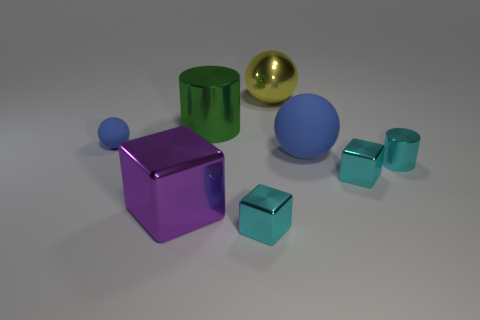Do the big rubber object and the small rubber ball have the same color?
Your answer should be very brief. Yes. What shape is the large green object?
Provide a succinct answer. Cylinder. How many tiny things are blue balls or cyan shiny cylinders?
Offer a terse response. 2. There is a yellow thing that is the same shape as the small blue object; what is its size?
Your answer should be very brief. Large. How many large metal things are in front of the green cylinder and behind the big purple metallic thing?
Provide a short and direct response. 0. There is a green shiny thing; is its shape the same as the rubber object that is to the right of the large yellow sphere?
Make the answer very short. No. Is the number of large metallic blocks that are in front of the big purple metal thing greater than the number of blue matte objects?
Offer a very short reply. No. Are there fewer metal things that are left of the purple shiny thing than blue rubber balls?
Provide a short and direct response. Yes. How many blocks have the same color as the large metallic cylinder?
Ensure brevity in your answer.  0. The big object that is both in front of the yellow thing and behind the tiny blue rubber ball is made of what material?
Your answer should be very brief. Metal. 